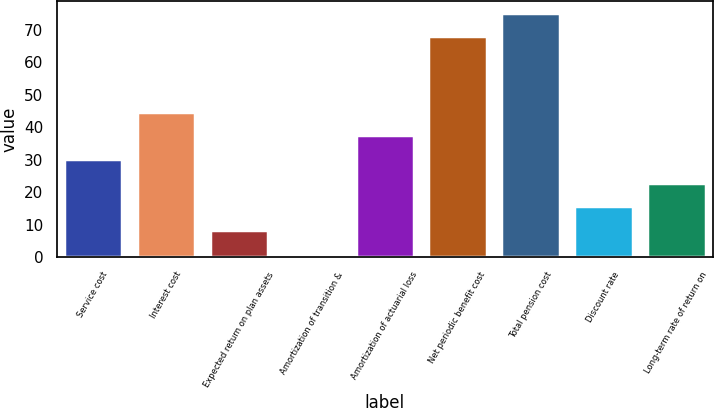<chart> <loc_0><loc_0><loc_500><loc_500><bar_chart><fcel>Service cost<fcel>Interest cost<fcel>Expected return on plan assets<fcel>Amortization of transition &<fcel>Amortization of actuarial loss<fcel>Net periodic benefit cost<fcel>Total pension cost<fcel>Discount rate<fcel>Long-term rate of return on<nl><fcel>30.2<fcel>44.8<fcel>8.3<fcel>1<fcel>37.5<fcel>68<fcel>75.3<fcel>15.6<fcel>22.9<nl></chart> 